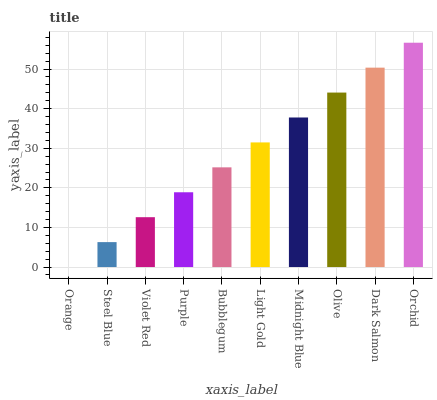Is Orange the minimum?
Answer yes or no. Yes. Is Orchid the maximum?
Answer yes or no. Yes. Is Steel Blue the minimum?
Answer yes or no. No. Is Steel Blue the maximum?
Answer yes or no. No. Is Steel Blue greater than Orange?
Answer yes or no. Yes. Is Orange less than Steel Blue?
Answer yes or no. Yes. Is Orange greater than Steel Blue?
Answer yes or no. No. Is Steel Blue less than Orange?
Answer yes or no. No. Is Light Gold the high median?
Answer yes or no. Yes. Is Bubblegum the low median?
Answer yes or no. Yes. Is Olive the high median?
Answer yes or no. No. Is Steel Blue the low median?
Answer yes or no. No. 